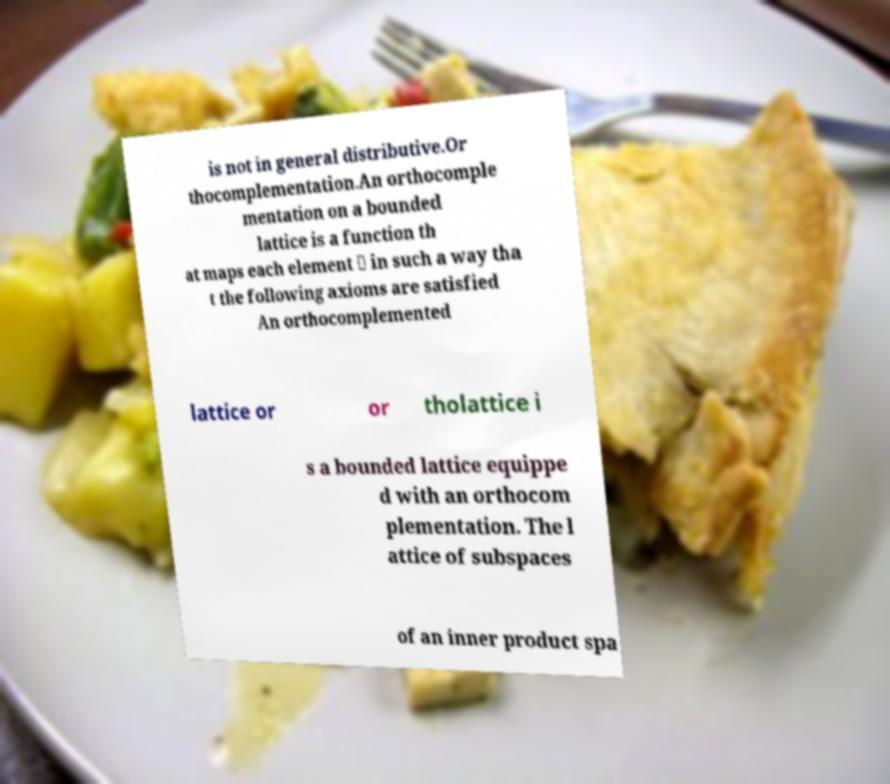There's text embedded in this image that I need extracted. Can you transcribe it verbatim? is not in general distributive.Or thocomplementation.An orthocomple mentation on a bounded lattice is a function th at maps each element ⊥ in such a way tha t the following axioms are satisfied An orthocomplemented lattice or or tholattice i s a bounded lattice equippe d with an orthocom plementation. The l attice of subspaces of an inner product spa 